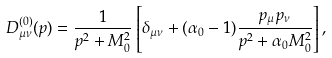<formula> <loc_0><loc_0><loc_500><loc_500>D _ { \mu \nu } ^ { ( 0 ) } ( { p } ) = \frac { 1 } { { p } ^ { 2 } + M _ { 0 } ^ { 2 } } \left [ \delta _ { \mu \nu } + ( \alpha _ { 0 } - 1 ) \frac { p _ { \mu } p _ { \nu } } { { p } ^ { 2 } + \alpha _ { 0 } M _ { 0 } ^ { 2 } } \right ] ,</formula> 